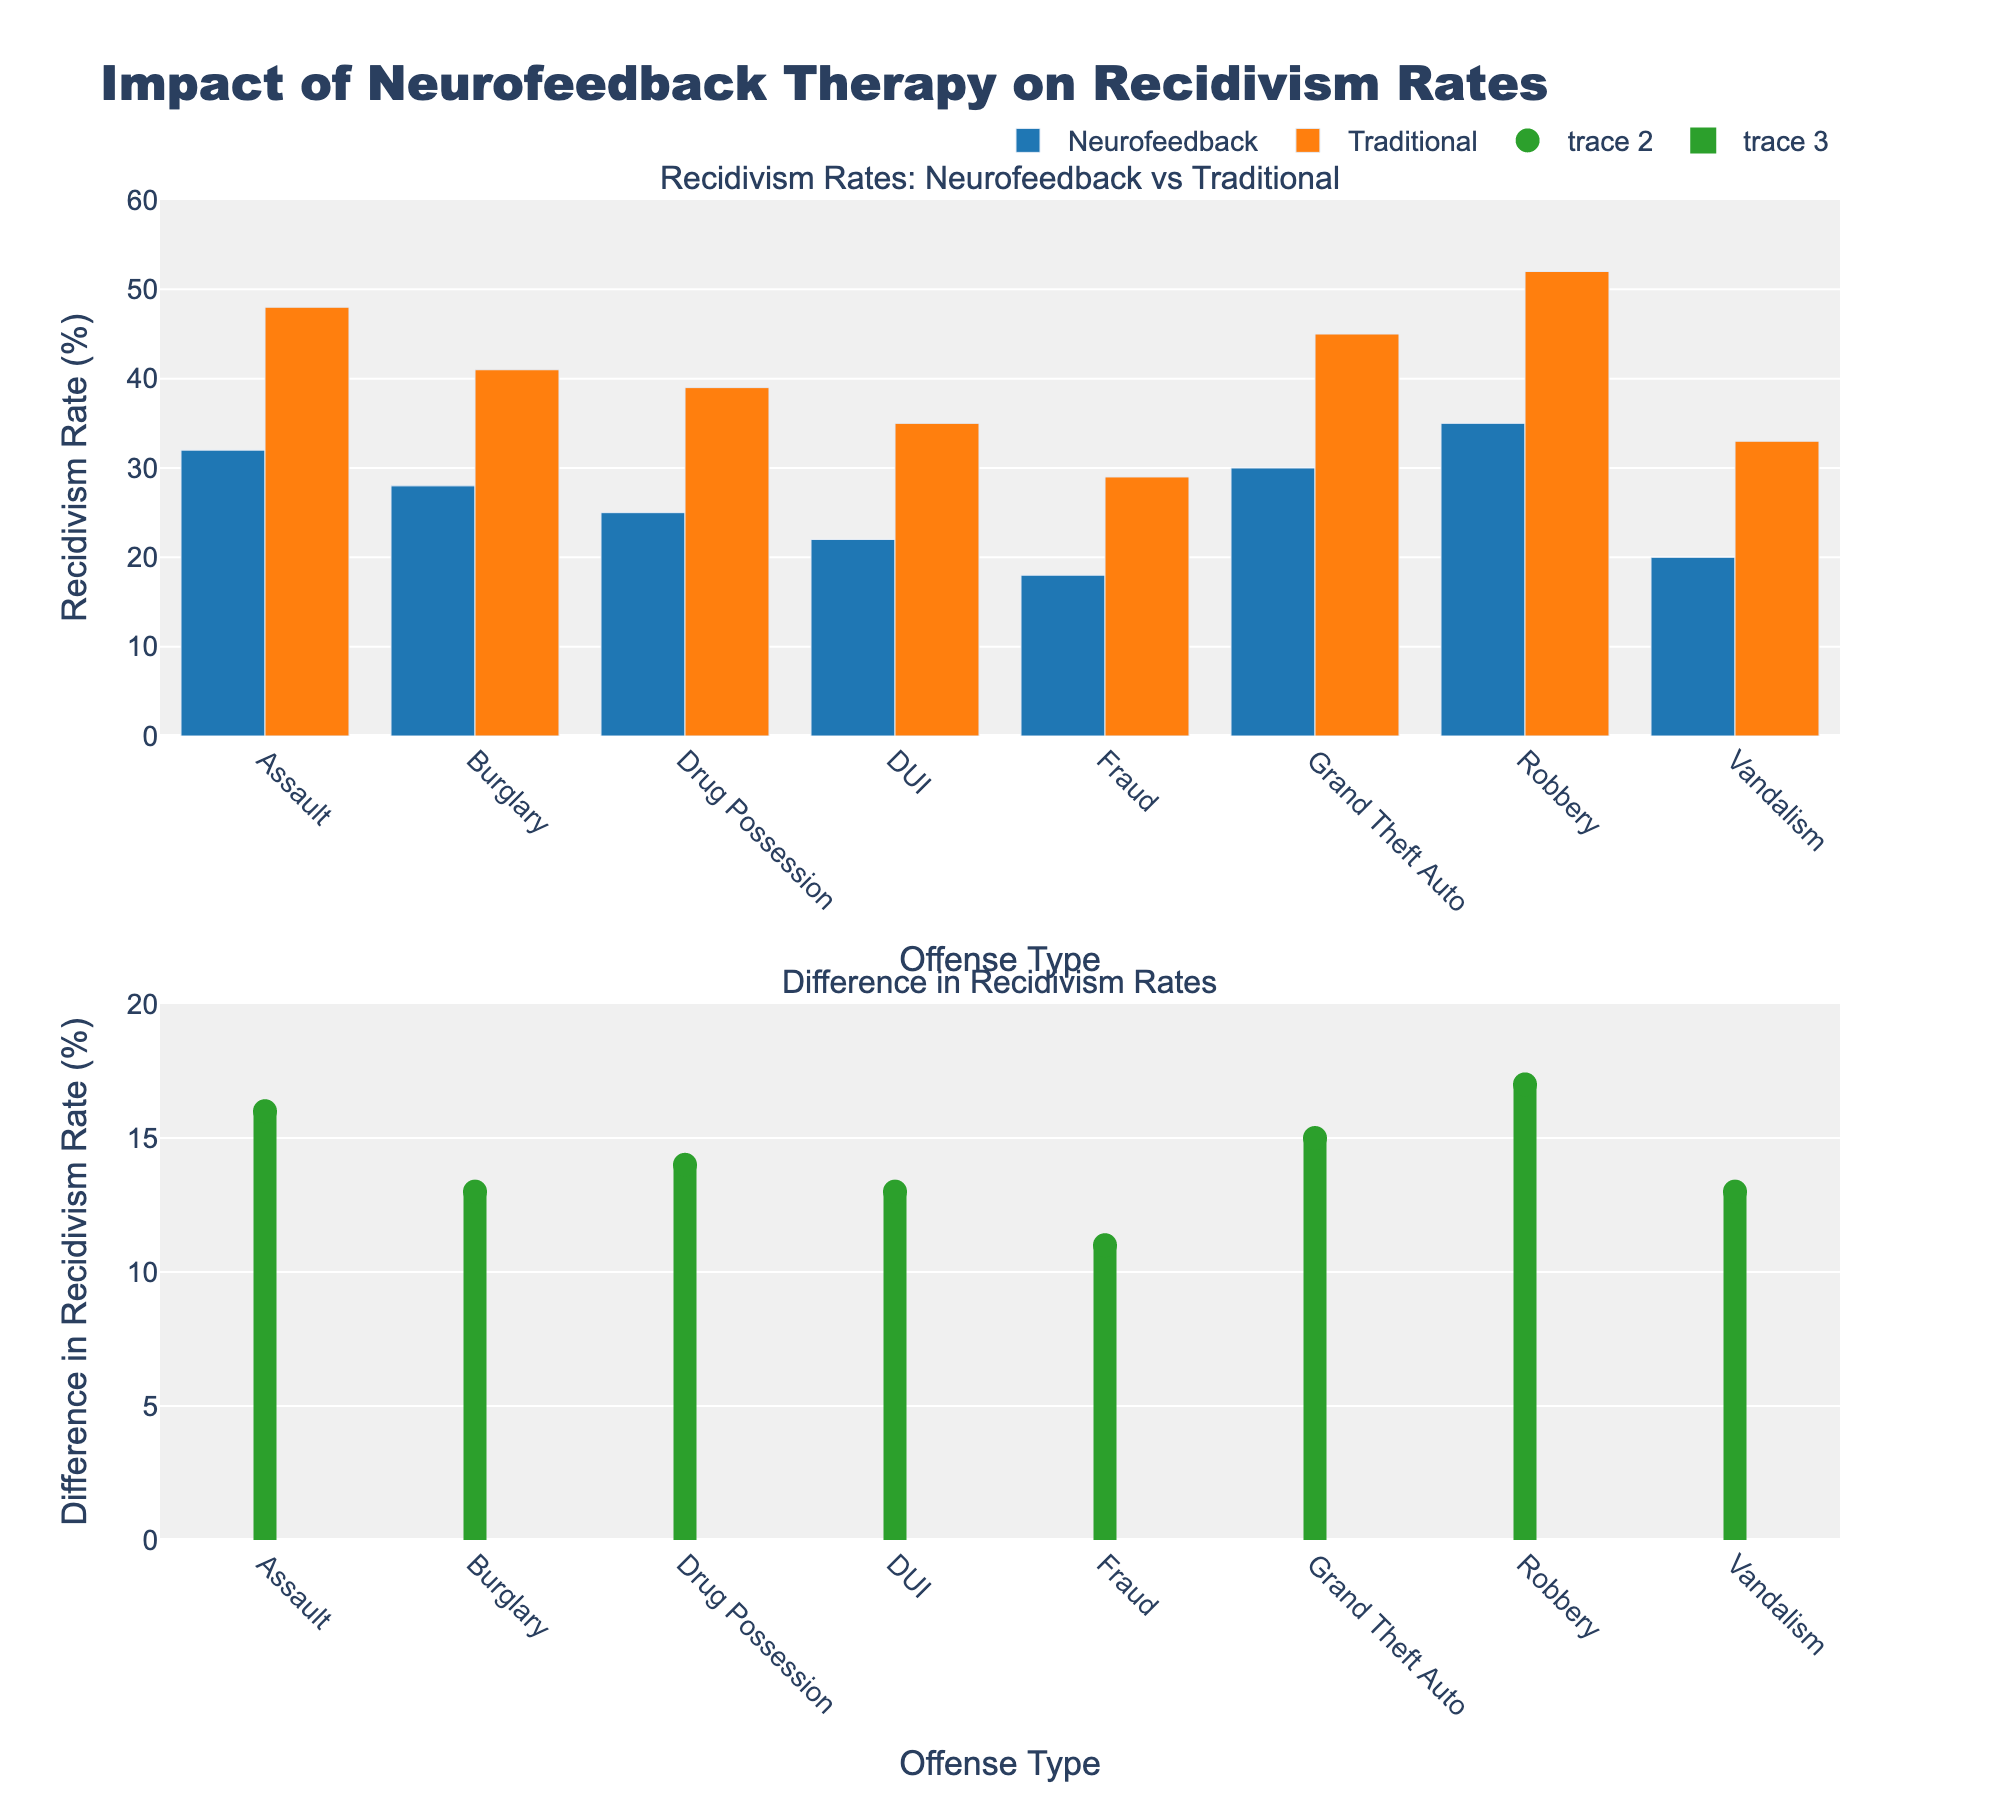What's the title of the figure? The title of the figure is located at the top. By reading the topmost text, we see it reads "Impact of Neurofeedback Therapy on Recidivism Rates".
Answer: Impact of Neurofeedback Therapy on Recidivism Rates Which offense type has the highest traditional recidivism rate? To find this, we compare the traditional recidivism rates among all offense types in the bar chart for recidivism rates. By visual inspection, Robbery has the highest traditional recidivism rate marked by the tallest orange bar.
Answer: Robbery What is the difference in recidivism rates for assault between neurofeedback and traditional rehabilitation? First, locate the recidivism rates for assault in both therapies. The blue bar for Neurofeedback is at 32%, and the orange bar for Traditional is at 48%. Subtract 32% from 48% to find the difference.
Answer: 16% Which offense type has the smallest difference in recidivism rates between neurofeedback and traditional rehabilitation? By examining the lollipop chart and focusing on the green markers, we note that the smallest difference is for Fraud, as it has the lowest green marker value.
Answer: Fraud Compare the recidivism rates of neurofeedback for assault and drug possession. Which is higher? Look at the blue bars for assault and drug possession in the bar chart for recidivism rates. The blue bar for assault is at 32%, and for drug possession, it is at 25%. 32% is greater than 25%.
Answer: Assault Which offense type shows the largest improvement (reduction) in recidivism rate with neurofeedback therapy compared to traditional rehabilitation? We need to look at the offense with the tallest green marker in the lollipop chart, indicating the largest difference in recidivism rates. For Robbery, the difference is the highest indicating the largest improvement.
Answer: Robbery How does the recidivism rate for DUI compare between neurofeedback and traditional rehabilitation? Examine the heights of the blue and orange bars for DUI. The neurofeedback recidivism rate is at 22%, and the traditional recidivism rate is at 35%. Neurofeedback shows a lower rate compared to traditional rehabilitation for DUI.
Answer: Neurofeedback is lower What is the average recidivism rate for traditional rehabilitation across all offense types? Sum up all traditional recidivism rates from the chart: 48% + 41% + 39% + 35% + 29% + 45% + 52% + 33% = 322%. Divide by the number of offense types (8) to get the average. 322%/8 = 40.25%.
Answer: 40.25% What is the total number of offense types where the neurofeedback recidivism rates are below 30%? Count the offense types in the blue bars where the rate is below 30%. These are Burglary (28%), Drug Possession (25%), DUI (22%), Fraud (18%), and Vandalism (20%). This gives us 5 offense types.
Answer: 5 What are the axis titles for the second subplot? Look at the second plot below the main bar chart. On the x-axis, it reads 'Offense Type', and on the y-axis, it reads 'Difference in Recidivism Rate (%)'.
Answer: Offense Type (x-axis), Difference in Recidivism Rate (%) (y-axis) 